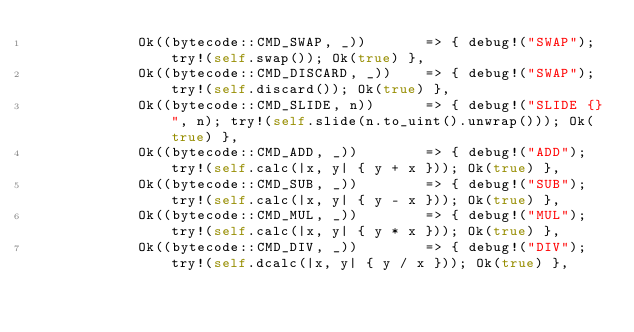Convert code to text. <code><loc_0><loc_0><loc_500><loc_500><_Rust_>            Ok((bytecode::CMD_SWAP, _))       => { debug!("SWAP"); try!(self.swap()); Ok(true) },
            Ok((bytecode::CMD_DISCARD, _))    => { debug!("SWAP"); try!(self.discard()); Ok(true) },
            Ok((bytecode::CMD_SLIDE, n))      => { debug!("SLIDE {}", n); try!(self.slide(n.to_uint().unwrap())); Ok(true) },
            Ok((bytecode::CMD_ADD, _))        => { debug!("ADD"); try!(self.calc(|x, y| { y + x })); Ok(true) },
            Ok((bytecode::CMD_SUB, _))        => { debug!("SUB"); try!(self.calc(|x, y| { y - x })); Ok(true) },
            Ok((bytecode::CMD_MUL, _))        => { debug!("MUL"); try!(self.calc(|x, y| { y * x })); Ok(true) },
            Ok((bytecode::CMD_DIV, _))        => { debug!("DIV"); try!(self.dcalc(|x, y| { y / x })); Ok(true) },</code> 